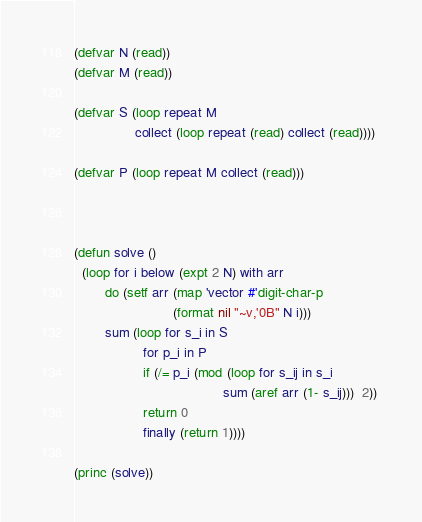<code> <loc_0><loc_0><loc_500><loc_500><_Lisp_>(defvar N (read))
(defvar M (read))

(defvar S (loop repeat M 
                collect (loop repeat (read) collect (read))))

(defvar P (loop repeat M collect (read)))



(defun solve ()
  (loop for i below (expt 2 N) with arr 
        do (setf arr (map 'vector #'digit-char-p 
                          (format nil "~v,'0B" N i)))
        sum (loop for s_i in S
                  for p_i in P
                  if (/= p_i (mod (loop for s_ij in s_i
                                       sum (aref arr (1- s_ij)))  2)) 
                  return 0
                  finally (return 1))))

(princ (solve))</code> 